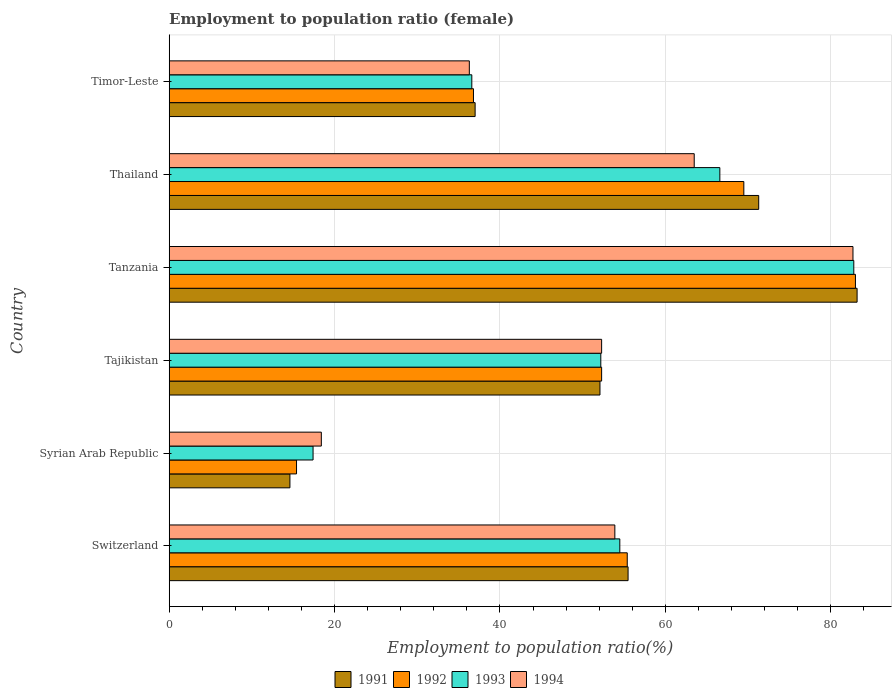Are the number of bars per tick equal to the number of legend labels?
Your answer should be very brief. Yes. How many bars are there on the 1st tick from the bottom?
Give a very brief answer. 4. What is the label of the 1st group of bars from the top?
Give a very brief answer. Timor-Leste. What is the employment to population ratio in 1994 in Syrian Arab Republic?
Offer a very short reply. 18.4. Across all countries, what is the maximum employment to population ratio in 1993?
Give a very brief answer. 82.8. Across all countries, what is the minimum employment to population ratio in 1992?
Give a very brief answer. 15.4. In which country was the employment to population ratio in 1994 maximum?
Make the answer very short. Tanzania. In which country was the employment to population ratio in 1993 minimum?
Your answer should be very brief. Syrian Arab Republic. What is the total employment to population ratio in 1992 in the graph?
Offer a very short reply. 312.4. What is the difference between the employment to population ratio in 1991 in Switzerland and that in Tajikistan?
Offer a terse response. 3.4. What is the difference between the employment to population ratio in 1991 in Syrian Arab Republic and the employment to population ratio in 1994 in Thailand?
Ensure brevity in your answer.  -48.9. What is the average employment to population ratio in 1991 per country?
Ensure brevity in your answer.  52.28. What is the difference between the employment to population ratio in 1993 and employment to population ratio in 1994 in Timor-Leste?
Your answer should be very brief. 0.3. What is the ratio of the employment to population ratio in 1991 in Syrian Arab Republic to that in Timor-Leste?
Your answer should be very brief. 0.39. Is the employment to population ratio in 1993 in Syrian Arab Republic less than that in Tajikistan?
Ensure brevity in your answer.  Yes. Is the difference between the employment to population ratio in 1993 in Tajikistan and Tanzania greater than the difference between the employment to population ratio in 1994 in Tajikistan and Tanzania?
Give a very brief answer. No. What is the difference between the highest and the second highest employment to population ratio in 1992?
Your answer should be very brief. 13.5. What is the difference between the highest and the lowest employment to population ratio in 1994?
Ensure brevity in your answer.  64.3. In how many countries, is the employment to population ratio in 1994 greater than the average employment to population ratio in 1994 taken over all countries?
Make the answer very short. 4. What does the 3rd bar from the top in Timor-Leste represents?
Ensure brevity in your answer.  1992. How many bars are there?
Provide a short and direct response. 24. Are all the bars in the graph horizontal?
Offer a terse response. Yes. How many countries are there in the graph?
Provide a short and direct response. 6. Are the values on the major ticks of X-axis written in scientific E-notation?
Provide a succinct answer. No. Does the graph contain any zero values?
Make the answer very short. No. Does the graph contain grids?
Keep it short and to the point. Yes. Where does the legend appear in the graph?
Your answer should be compact. Bottom center. How many legend labels are there?
Ensure brevity in your answer.  4. How are the legend labels stacked?
Provide a short and direct response. Horizontal. What is the title of the graph?
Your answer should be very brief. Employment to population ratio (female). Does "1978" appear as one of the legend labels in the graph?
Your answer should be compact. No. What is the label or title of the X-axis?
Ensure brevity in your answer.  Employment to population ratio(%). What is the label or title of the Y-axis?
Make the answer very short. Country. What is the Employment to population ratio(%) in 1991 in Switzerland?
Ensure brevity in your answer.  55.5. What is the Employment to population ratio(%) of 1992 in Switzerland?
Your answer should be very brief. 55.4. What is the Employment to population ratio(%) in 1993 in Switzerland?
Your response must be concise. 54.5. What is the Employment to population ratio(%) in 1994 in Switzerland?
Offer a very short reply. 53.9. What is the Employment to population ratio(%) of 1991 in Syrian Arab Republic?
Offer a terse response. 14.6. What is the Employment to population ratio(%) of 1992 in Syrian Arab Republic?
Make the answer very short. 15.4. What is the Employment to population ratio(%) of 1993 in Syrian Arab Republic?
Make the answer very short. 17.4. What is the Employment to population ratio(%) in 1994 in Syrian Arab Republic?
Provide a succinct answer. 18.4. What is the Employment to population ratio(%) in 1991 in Tajikistan?
Provide a succinct answer. 52.1. What is the Employment to population ratio(%) of 1992 in Tajikistan?
Make the answer very short. 52.3. What is the Employment to population ratio(%) in 1993 in Tajikistan?
Your response must be concise. 52.2. What is the Employment to population ratio(%) in 1994 in Tajikistan?
Your answer should be very brief. 52.3. What is the Employment to population ratio(%) in 1991 in Tanzania?
Provide a short and direct response. 83.2. What is the Employment to population ratio(%) of 1993 in Tanzania?
Offer a terse response. 82.8. What is the Employment to population ratio(%) in 1994 in Tanzania?
Offer a very short reply. 82.7. What is the Employment to population ratio(%) in 1991 in Thailand?
Provide a succinct answer. 71.3. What is the Employment to population ratio(%) in 1992 in Thailand?
Your answer should be compact. 69.5. What is the Employment to population ratio(%) in 1993 in Thailand?
Your answer should be compact. 66.6. What is the Employment to population ratio(%) in 1994 in Thailand?
Ensure brevity in your answer.  63.5. What is the Employment to population ratio(%) of 1992 in Timor-Leste?
Your answer should be compact. 36.8. What is the Employment to population ratio(%) of 1993 in Timor-Leste?
Ensure brevity in your answer.  36.6. What is the Employment to population ratio(%) of 1994 in Timor-Leste?
Give a very brief answer. 36.3. Across all countries, what is the maximum Employment to population ratio(%) in 1991?
Your answer should be very brief. 83.2. Across all countries, what is the maximum Employment to population ratio(%) in 1993?
Give a very brief answer. 82.8. Across all countries, what is the maximum Employment to population ratio(%) in 1994?
Offer a terse response. 82.7. Across all countries, what is the minimum Employment to population ratio(%) in 1991?
Your answer should be compact. 14.6. Across all countries, what is the minimum Employment to population ratio(%) in 1992?
Provide a succinct answer. 15.4. Across all countries, what is the minimum Employment to population ratio(%) of 1993?
Provide a short and direct response. 17.4. Across all countries, what is the minimum Employment to population ratio(%) of 1994?
Your answer should be compact. 18.4. What is the total Employment to population ratio(%) of 1991 in the graph?
Provide a short and direct response. 313.7. What is the total Employment to population ratio(%) in 1992 in the graph?
Ensure brevity in your answer.  312.4. What is the total Employment to population ratio(%) of 1993 in the graph?
Give a very brief answer. 310.1. What is the total Employment to population ratio(%) in 1994 in the graph?
Offer a terse response. 307.1. What is the difference between the Employment to population ratio(%) of 1991 in Switzerland and that in Syrian Arab Republic?
Your answer should be compact. 40.9. What is the difference between the Employment to population ratio(%) of 1993 in Switzerland and that in Syrian Arab Republic?
Offer a very short reply. 37.1. What is the difference between the Employment to population ratio(%) in 1994 in Switzerland and that in Syrian Arab Republic?
Provide a short and direct response. 35.5. What is the difference between the Employment to population ratio(%) of 1993 in Switzerland and that in Tajikistan?
Keep it short and to the point. 2.3. What is the difference between the Employment to population ratio(%) of 1994 in Switzerland and that in Tajikistan?
Ensure brevity in your answer.  1.6. What is the difference between the Employment to population ratio(%) of 1991 in Switzerland and that in Tanzania?
Provide a succinct answer. -27.7. What is the difference between the Employment to population ratio(%) of 1992 in Switzerland and that in Tanzania?
Give a very brief answer. -27.6. What is the difference between the Employment to population ratio(%) of 1993 in Switzerland and that in Tanzania?
Your answer should be very brief. -28.3. What is the difference between the Employment to population ratio(%) of 1994 in Switzerland and that in Tanzania?
Ensure brevity in your answer.  -28.8. What is the difference between the Employment to population ratio(%) in 1991 in Switzerland and that in Thailand?
Offer a very short reply. -15.8. What is the difference between the Employment to population ratio(%) of 1992 in Switzerland and that in Thailand?
Give a very brief answer. -14.1. What is the difference between the Employment to population ratio(%) of 1993 in Switzerland and that in Thailand?
Provide a succinct answer. -12.1. What is the difference between the Employment to population ratio(%) of 1991 in Switzerland and that in Timor-Leste?
Your answer should be compact. 18.5. What is the difference between the Employment to population ratio(%) in 1994 in Switzerland and that in Timor-Leste?
Your answer should be very brief. 17.6. What is the difference between the Employment to population ratio(%) in 1991 in Syrian Arab Republic and that in Tajikistan?
Your answer should be very brief. -37.5. What is the difference between the Employment to population ratio(%) in 1992 in Syrian Arab Republic and that in Tajikistan?
Offer a terse response. -36.9. What is the difference between the Employment to population ratio(%) in 1993 in Syrian Arab Republic and that in Tajikistan?
Provide a short and direct response. -34.8. What is the difference between the Employment to population ratio(%) in 1994 in Syrian Arab Republic and that in Tajikistan?
Your answer should be very brief. -33.9. What is the difference between the Employment to population ratio(%) of 1991 in Syrian Arab Republic and that in Tanzania?
Provide a succinct answer. -68.6. What is the difference between the Employment to population ratio(%) in 1992 in Syrian Arab Republic and that in Tanzania?
Provide a succinct answer. -67.6. What is the difference between the Employment to population ratio(%) in 1993 in Syrian Arab Republic and that in Tanzania?
Your answer should be compact. -65.4. What is the difference between the Employment to population ratio(%) in 1994 in Syrian Arab Republic and that in Tanzania?
Your answer should be compact. -64.3. What is the difference between the Employment to population ratio(%) of 1991 in Syrian Arab Republic and that in Thailand?
Your answer should be very brief. -56.7. What is the difference between the Employment to population ratio(%) in 1992 in Syrian Arab Republic and that in Thailand?
Keep it short and to the point. -54.1. What is the difference between the Employment to population ratio(%) of 1993 in Syrian Arab Republic and that in Thailand?
Offer a very short reply. -49.2. What is the difference between the Employment to population ratio(%) in 1994 in Syrian Arab Republic and that in Thailand?
Offer a terse response. -45.1. What is the difference between the Employment to population ratio(%) of 1991 in Syrian Arab Republic and that in Timor-Leste?
Make the answer very short. -22.4. What is the difference between the Employment to population ratio(%) of 1992 in Syrian Arab Republic and that in Timor-Leste?
Keep it short and to the point. -21.4. What is the difference between the Employment to population ratio(%) of 1993 in Syrian Arab Republic and that in Timor-Leste?
Offer a very short reply. -19.2. What is the difference between the Employment to population ratio(%) of 1994 in Syrian Arab Republic and that in Timor-Leste?
Make the answer very short. -17.9. What is the difference between the Employment to population ratio(%) in 1991 in Tajikistan and that in Tanzania?
Make the answer very short. -31.1. What is the difference between the Employment to population ratio(%) of 1992 in Tajikistan and that in Tanzania?
Make the answer very short. -30.7. What is the difference between the Employment to population ratio(%) in 1993 in Tajikistan and that in Tanzania?
Offer a very short reply. -30.6. What is the difference between the Employment to population ratio(%) in 1994 in Tajikistan and that in Tanzania?
Your answer should be very brief. -30.4. What is the difference between the Employment to population ratio(%) of 1991 in Tajikistan and that in Thailand?
Your answer should be compact. -19.2. What is the difference between the Employment to population ratio(%) of 1992 in Tajikistan and that in Thailand?
Make the answer very short. -17.2. What is the difference between the Employment to population ratio(%) in 1993 in Tajikistan and that in Thailand?
Ensure brevity in your answer.  -14.4. What is the difference between the Employment to population ratio(%) of 1994 in Tajikistan and that in Thailand?
Offer a terse response. -11.2. What is the difference between the Employment to population ratio(%) of 1991 in Tajikistan and that in Timor-Leste?
Provide a short and direct response. 15.1. What is the difference between the Employment to population ratio(%) of 1992 in Tajikistan and that in Timor-Leste?
Your answer should be very brief. 15.5. What is the difference between the Employment to population ratio(%) of 1994 in Tajikistan and that in Timor-Leste?
Offer a terse response. 16. What is the difference between the Employment to population ratio(%) in 1992 in Tanzania and that in Thailand?
Offer a terse response. 13.5. What is the difference between the Employment to population ratio(%) of 1993 in Tanzania and that in Thailand?
Your answer should be very brief. 16.2. What is the difference between the Employment to population ratio(%) of 1994 in Tanzania and that in Thailand?
Provide a succinct answer. 19.2. What is the difference between the Employment to population ratio(%) of 1991 in Tanzania and that in Timor-Leste?
Offer a terse response. 46.2. What is the difference between the Employment to population ratio(%) of 1992 in Tanzania and that in Timor-Leste?
Your answer should be very brief. 46.2. What is the difference between the Employment to population ratio(%) of 1993 in Tanzania and that in Timor-Leste?
Offer a terse response. 46.2. What is the difference between the Employment to population ratio(%) in 1994 in Tanzania and that in Timor-Leste?
Provide a short and direct response. 46.4. What is the difference between the Employment to population ratio(%) of 1991 in Thailand and that in Timor-Leste?
Provide a succinct answer. 34.3. What is the difference between the Employment to population ratio(%) in 1992 in Thailand and that in Timor-Leste?
Provide a short and direct response. 32.7. What is the difference between the Employment to population ratio(%) of 1993 in Thailand and that in Timor-Leste?
Offer a very short reply. 30. What is the difference between the Employment to population ratio(%) in 1994 in Thailand and that in Timor-Leste?
Your answer should be very brief. 27.2. What is the difference between the Employment to population ratio(%) in 1991 in Switzerland and the Employment to population ratio(%) in 1992 in Syrian Arab Republic?
Your answer should be compact. 40.1. What is the difference between the Employment to population ratio(%) of 1991 in Switzerland and the Employment to population ratio(%) of 1993 in Syrian Arab Republic?
Give a very brief answer. 38.1. What is the difference between the Employment to population ratio(%) of 1991 in Switzerland and the Employment to population ratio(%) of 1994 in Syrian Arab Republic?
Offer a terse response. 37.1. What is the difference between the Employment to population ratio(%) of 1992 in Switzerland and the Employment to population ratio(%) of 1993 in Syrian Arab Republic?
Provide a short and direct response. 38. What is the difference between the Employment to population ratio(%) in 1993 in Switzerland and the Employment to population ratio(%) in 1994 in Syrian Arab Republic?
Offer a very short reply. 36.1. What is the difference between the Employment to population ratio(%) in 1991 in Switzerland and the Employment to population ratio(%) in 1993 in Tajikistan?
Keep it short and to the point. 3.3. What is the difference between the Employment to population ratio(%) of 1991 in Switzerland and the Employment to population ratio(%) of 1994 in Tajikistan?
Keep it short and to the point. 3.2. What is the difference between the Employment to population ratio(%) in 1992 in Switzerland and the Employment to population ratio(%) in 1993 in Tajikistan?
Your response must be concise. 3.2. What is the difference between the Employment to population ratio(%) of 1991 in Switzerland and the Employment to population ratio(%) of 1992 in Tanzania?
Keep it short and to the point. -27.5. What is the difference between the Employment to population ratio(%) in 1991 in Switzerland and the Employment to population ratio(%) in 1993 in Tanzania?
Make the answer very short. -27.3. What is the difference between the Employment to population ratio(%) in 1991 in Switzerland and the Employment to population ratio(%) in 1994 in Tanzania?
Your answer should be compact. -27.2. What is the difference between the Employment to population ratio(%) of 1992 in Switzerland and the Employment to population ratio(%) of 1993 in Tanzania?
Your answer should be compact. -27.4. What is the difference between the Employment to population ratio(%) of 1992 in Switzerland and the Employment to population ratio(%) of 1994 in Tanzania?
Your response must be concise. -27.3. What is the difference between the Employment to population ratio(%) of 1993 in Switzerland and the Employment to population ratio(%) of 1994 in Tanzania?
Keep it short and to the point. -28.2. What is the difference between the Employment to population ratio(%) of 1991 in Switzerland and the Employment to population ratio(%) of 1992 in Thailand?
Your answer should be very brief. -14. What is the difference between the Employment to population ratio(%) of 1991 in Switzerland and the Employment to population ratio(%) of 1994 in Thailand?
Provide a succinct answer. -8. What is the difference between the Employment to population ratio(%) of 1993 in Switzerland and the Employment to population ratio(%) of 1994 in Thailand?
Your answer should be compact. -9. What is the difference between the Employment to population ratio(%) of 1991 in Switzerland and the Employment to population ratio(%) of 1992 in Timor-Leste?
Offer a terse response. 18.7. What is the difference between the Employment to population ratio(%) of 1991 in Switzerland and the Employment to population ratio(%) of 1993 in Timor-Leste?
Make the answer very short. 18.9. What is the difference between the Employment to population ratio(%) in 1991 in Switzerland and the Employment to population ratio(%) in 1994 in Timor-Leste?
Ensure brevity in your answer.  19.2. What is the difference between the Employment to population ratio(%) of 1992 in Switzerland and the Employment to population ratio(%) of 1993 in Timor-Leste?
Ensure brevity in your answer.  18.8. What is the difference between the Employment to population ratio(%) of 1992 in Switzerland and the Employment to population ratio(%) of 1994 in Timor-Leste?
Make the answer very short. 19.1. What is the difference between the Employment to population ratio(%) in 1993 in Switzerland and the Employment to population ratio(%) in 1994 in Timor-Leste?
Offer a terse response. 18.2. What is the difference between the Employment to population ratio(%) of 1991 in Syrian Arab Republic and the Employment to population ratio(%) of 1992 in Tajikistan?
Offer a terse response. -37.7. What is the difference between the Employment to population ratio(%) of 1991 in Syrian Arab Republic and the Employment to population ratio(%) of 1993 in Tajikistan?
Make the answer very short. -37.6. What is the difference between the Employment to population ratio(%) in 1991 in Syrian Arab Republic and the Employment to population ratio(%) in 1994 in Tajikistan?
Ensure brevity in your answer.  -37.7. What is the difference between the Employment to population ratio(%) of 1992 in Syrian Arab Republic and the Employment to population ratio(%) of 1993 in Tajikistan?
Offer a terse response. -36.8. What is the difference between the Employment to population ratio(%) in 1992 in Syrian Arab Republic and the Employment to population ratio(%) in 1994 in Tajikistan?
Your answer should be compact. -36.9. What is the difference between the Employment to population ratio(%) in 1993 in Syrian Arab Republic and the Employment to population ratio(%) in 1994 in Tajikistan?
Provide a short and direct response. -34.9. What is the difference between the Employment to population ratio(%) in 1991 in Syrian Arab Republic and the Employment to population ratio(%) in 1992 in Tanzania?
Provide a short and direct response. -68.4. What is the difference between the Employment to population ratio(%) in 1991 in Syrian Arab Republic and the Employment to population ratio(%) in 1993 in Tanzania?
Offer a very short reply. -68.2. What is the difference between the Employment to population ratio(%) of 1991 in Syrian Arab Republic and the Employment to population ratio(%) of 1994 in Tanzania?
Your response must be concise. -68.1. What is the difference between the Employment to population ratio(%) of 1992 in Syrian Arab Republic and the Employment to population ratio(%) of 1993 in Tanzania?
Ensure brevity in your answer.  -67.4. What is the difference between the Employment to population ratio(%) of 1992 in Syrian Arab Republic and the Employment to population ratio(%) of 1994 in Tanzania?
Keep it short and to the point. -67.3. What is the difference between the Employment to population ratio(%) of 1993 in Syrian Arab Republic and the Employment to population ratio(%) of 1994 in Tanzania?
Make the answer very short. -65.3. What is the difference between the Employment to population ratio(%) of 1991 in Syrian Arab Republic and the Employment to population ratio(%) of 1992 in Thailand?
Offer a terse response. -54.9. What is the difference between the Employment to population ratio(%) of 1991 in Syrian Arab Republic and the Employment to population ratio(%) of 1993 in Thailand?
Offer a terse response. -52. What is the difference between the Employment to population ratio(%) in 1991 in Syrian Arab Republic and the Employment to population ratio(%) in 1994 in Thailand?
Make the answer very short. -48.9. What is the difference between the Employment to population ratio(%) of 1992 in Syrian Arab Republic and the Employment to population ratio(%) of 1993 in Thailand?
Keep it short and to the point. -51.2. What is the difference between the Employment to population ratio(%) in 1992 in Syrian Arab Republic and the Employment to population ratio(%) in 1994 in Thailand?
Ensure brevity in your answer.  -48.1. What is the difference between the Employment to population ratio(%) of 1993 in Syrian Arab Republic and the Employment to population ratio(%) of 1994 in Thailand?
Make the answer very short. -46.1. What is the difference between the Employment to population ratio(%) in 1991 in Syrian Arab Republic and the Employment to population ratio(%) in 1992 in Timor-Leste?
Provide a short and direct response. -22.2. What is the difference between the Employment to population ratio(%) of 1991 in Syrian Arab Republic and the Employment to population ratio(%) of 1993 in Timor-Leste?
Your response must be concise. -22. What is the difference between the Employment to population ratio(%) of 1991 in Syrian Arab Republic and the Employment to population ratio(%) of 1994 in Timor-Leste?
Your answer should be compact. -21.7. What is the difference between the Employment to population ratio(%) of 1992 in Syrian Arab Republic and the Employment to population ratio(%) of 1993 in Timor-Leste?
Your response must be concise. -21.2. What is the difference between the Employment to population ratio(%) of 1992 in Syrian Arab Republic and the Employment to population ratio(%) of 1994 in Timor-Leste?
Your response must be concise. -20.9. What is the difference between the Employment to population ratio(%) in 1993 in Syrian Arab Republic and the Employment to population ratio(%) in 1994 in Timor-Leste?
Give a very brief answer. -18.9. What is the difference between the Employment to population ratio(%) in 1991 in Tajikistan and the Employment to population ratio(%) in 1992 in Tanzania?
Keep it short and to the point. -30.9. What is the difference between the Employment to population ratio(%) in 1991 in Tajikistan and the Employment to population ratio(%) in 1993 in Tanzania?
Your response must be concise. -30.7. What is the difference between the Employment to population ratio(%) of 1991 in Tajikistan and the Employment to population ratio(%) of 1994 in Tanzania?
Ensure brevity in your answer.  -30.6. What is the difference between the Employment to population ratio(%) of 1992 in Tajikistan and the Employment to population ratio(%) of 1993 in Tanzania?
Your response must be concise. -30.5. What is the difference between the Employment to population ratio(%) in 1992 in Tajikistan and the Employment to population ratio(%) in 1994 in Tanzania?
Your response must be concise. -30.4. What is the difference between the Employment to population ratio(%) in 1993 in Tajikistan and the Employment to population ratio(%) in 1994 in Tanzania?
Provide a short and direct response. -30.5. What is the difference between the Employment to population ratio(%) of 1991 in Tajikistan and the Employment to population ratio(%) of 1992 in Thailand?
Make the answer very short. -17.4. What is the difference between the Employment to population ratio(%) of 1991 in Tajikistan and the Employment to population ratio(%) of 1993 in Thailand?
Give a very brief answer. -14.5. What is the difference between the Employment to population ratio(%) in 1992 in Tajikistan and the Employment to population ratio(%) in 1993 in Thailand?
Your answer should be compact. -14.3. What is the difference between the Employment to population ratio(%) in 1991 in Tajikistan and the Employment to population ratio(%) in 1992 in Timor-Leste?
Ensure brevity in your answer.  15.3. What is the difference between the Employment to population ratio(%) of 1992 in Tajikistan and the Employment to population ratio(%) of 1993 in Timor-Leste?
Your answer should be compact. 15.7. What is the difference between the Employment to population ratio(%) in 1991 in Tanzania and the Employment to population ratio(%) in 1992 in Thailand?
Your response must be concise. 13.7. What is the difference between the Employment to population ratio(%) in 1991 in Tanzania and the Employment to population ratio(%) in 1993 in Thailand?
Provide a succinct answer. 16.6. What is the difference between the Employment to population ratio(%) of 1992 in Tanzania and the Employment to population ratio(%) of 1994 in Thailand?
Your answer should be compact. 19.5. What is the difference between the Employment to population ratio(%) in 1993 in Tanzania and the Employment to population ratio(%) in 1994 in Thailand?
Offer a terse response. 19.3. What is the difference between the Employment to population ratio(%) of 1991 in Tanzania and the Employment to population ratio(%) of 1992 in Timor-Leste?
Make the answer very short. 46.4. What is the difference between the Employment to population ratio(%) of 1991 in Tanzania and the Employment to population ratio(%) of 1993 in Timor-Leste?
Your answer should be very brief. 46.6. What is the difference between the Employment to population ratio(%) of 1991 in Tanzania and the Employment to population ratio(%) of 1994 in Timor-Leste?
Keep it short and to the point. 46.9. What is the difference between the Employment to population ratio(%) in 1992 in Tanzania and the Employment to population ratio(%) in 1993 in Timor-Leste?
Make the answer very short. 46.4. What is the difference between the Employment to population ratio(%) of 1992 in Tanzania and the Employment to population ratio(%) of 1994 in Timor-Leste?
Your answer should be very brief. 46.7. What is the difference between the Employment to population ratio(%) in 1993 in Tanzania and the Employment to population ratio(%) in 1994 in Timor-Leste?
Keep it short and to the point. 46.5. What is the difference between the Employment to population ratio(%) in 1991 in Thailand and the Employment to population ratio(%) in 1992 in Timor-Leste?
Offer a very short reply. 34.5. What is the difference between the Employment to population ratio(%) in 1991 in Thailand and the Employment to population ratio(%) in 1993 in Timor-Leste?
Give a very brief answer. 34.7. What is the difference between the Employment to population ratio(%) in 1991 in Thailand and the Employment to population ratio(%) in 1994 in Timor-Leste?
Your answer should be very brief. 35. What is the difference between the Employment to population ratio(%) in 1992 in Thailand and the Employment to population ratio(%) in 1993 in Timor-Leste?
Your response must be concise. 32.9. What is the difference between the Employment to population ratio(%) in 1992 in Thailand and the Employment to population ratio(%) in 1994 in Timor-Leste?
Keep it short and to the point. 33.2. What is the difference between the Employment to population ratio(%) of 1993 in Thailand and the Employment to population ratio(%) of 1994 in Timor-Leste?
Your response must be concise. 30.3. What is the average Employment to population ratio(%) of 1991 per country?
Your response must be concise. 52.28. What is the average Employment to population ratio(%) in 1992 per country?
Provide a short and direct response. 52.07. What is the average Employment to population ratio(%) in 1993 per country?
Provide a short and direct response. 51.68. What is the average Employment to population ratio(%) of 1994 per country?
Your answer should be compact. 51.18. What is the difference between the Employment to population ratio(%) of 1991 and Employment to population ratio(%) of 1994 in Switzerland?
Make the answer very short. 1.6. What is the difference between the Employment to population ratio(%) of 1992 and Employment to population ratio(%) of 1994 in Switzerland?
Give a very brief answer. 1.5. What is the difference between the Employment to population ratio(%) in 1992 and Employment to population ratio(%) in 1993 in Syrian Arab Republic?
Provide a short and direct response. -2. What is the difference between the Employment to population ratio(%) in 1992 and Employment to population ratio(%) in 1994 in Syrian Arab Republic?
Your answer should be very brief. -3. What is the difference between the Employment to population ratio(%) in 1993 and Employment to population ratio(%) in 1994 in Syrian Arab Republic?
Ensure brevity in your answer.  -1. What is the difference between the Employment to population ratio(%) in 1991 and Employment to population ratio(%) in 1992 in Tajikistan?
Make the answer very short. -0.2. What is the difference between the Employment to population ratio(%) in 1991 and Employment to population ratio(%) in 1994 in Tajikistan?
Your answer should be very brief. -0.2. What is the difference between the Employment to population ratio(%) of 1993 and Employment to population ratio(%) of 1994 in Tajikistan?
Keep it short and to the point. -0.1. What is the difference between the Employment to population ratio(%) in 1991 and Employment to population ratio(%) in 1992 in Tanzania?
Provide a succinct answer. 0.2. What is the difference between the Employment to population ratio(%) of 1991 and Employment to population ratio(%) of 1994 in Tanzania?
Provide a succinct answer. 0.5. What is the difference between the Employment to population ratio(%) of 1992 and Employment to population ratio(%) of 1993 in Tanzania?
Give a very brief answer. 0.2. What is the difference between the Employment to population ratio(%) of 1992 and Employment to population ratio(%) of 1994 in Tanzania?
Offer a very short reply. 0.3. What is the difference between the Employment to population ratio(%) of 1991 and Employment to population ratio(%) of 1992 in Thailand?
Keep it short and to the point. 1.8. What is the difference between the Employment to population ratio(%) of 1991 and Employment to population ratio(%) of 1993 in Thailand?
Your answer should be very brief. 4.7. What is the difference between the Employment to population ratio(%) in 1993 and Employment to population ratio(%) in 1994 in Thailand?
Your answer should be compact. 3.1. What is the difference between the Employment to population ratio(%) in 1991 and Employment to population ratio(%) in 1994 in Timor-Leste?
Your answer should be very brief. 0.7. What is the difference between the Employment to population ratio(%) of 1992 and Employment to population ratio(%) of 1993 in Timor-Leste?
Your answer should be very brief. 0.2. What is the difference between the Employment to population ratio(%) in 1992 and Employment to population ratio(%) in 1994 in Timor-Leste?
Your answer should be very brief. 0.5. What is the ratio of the Employment to population ratio(%) of 1991 in Switzerland to that in Syrian Arab Republic?
Keep it short and to the point. 3.8. What is the ratio of the Employment to population ratio(%) of 1992 in Switzerland to that in Syrian Arab Republic?
Provide a short and direct response. 3.6. What is the ratio of the Employment to population ratio(%) of 1993 in Switzerland to that in Syrian Arab Republic?
Ensure brevity in your answer.  3.13. What is the ratio of the Employment to population ratio(%) of 1994 in Switzerland to that in Syrian Arab Republic?
Your answer should be compact. 2.93. What is the ratio of the Employment to population ratio(%) of 1991 in Switzerland to that in Tajikistan?
Your answer should be very brief. 1.07. What is the ratio of the Employment to population ratio(%) in 1992 in Switzerland to that in Tajikistan?
Your answer should be very brief. 1.06. What is the ratio of the Employment to population ratio(%) in 1993 in Switzerland to that in Tajikistan?
Your answer should be compact. 1.04. What is the ratio of the Employment to population ratio(%) of 1994 in Switzerland to that in Tajikistan?
Provide a succinct answer. 1.03. What is the ratio of the Employment to population ratio(%) in 1991 in Switzerland to that in Tanzania?
Give a very brief answer. 0.67. What is the ratio of the Employment to population ratio(%) of 1992 in Switzerland to that in Tanzania?
Make the answer very short. 0.67. What is the ratio of the Employment to population ratio(%) of 1993 in Switzerland to that in Tanzania?
Your response must be concise. 0.66. What is the ratio of the Employment to population ratio(%) in 1994 in Switzerland to that in Tanzania?
Provide a succinct answer. 0.65. What is the ratio of the Employment to population ratio(%) of 1991 in Switzerland to that in Thailand?
Your answer should be compact. 0.78. What is the ratio of the Employment to population ratio(%) of 1992 in Switzerland to that in Thailand?
Your answer should be very brief. 0.8. What is the ratio of the Employment to population ratio(%) in 1993 in Switzerland to that in Thailand?
Your response must be concise. 0.82. What is the ratio of the Employment to population ratio(%) of 1994 in Switzerland to that in Thailand?
Provide a succinct answer. 0.85. What is the ratio of the Employment to population ratio(%) in 1992 in Switzerland to that in Timor-Leste?
Keep it short and to the point. 1.51. What is the ratio of the Employment to population ratio(%) in 1993 in Switzerland to that in Timor-Leste?
Keep it short and to the point. 1.49. What is the ratio of the Employment to population ratio(%) in 1994 in Switzerland to that in Timor-Leste?
Offer a terse response. 1.48. What is the ratio of the Employment to population ratio(%) of 1991 in Syrian Arab Republic to that in Tajikistan?
Offer a terse response. 0.28. What is the ratio of the Employment to population ratio(%) of 1992 in Syrian Arab Republic to that in Tajikistan?
Offer a terse response. 0.29. What is the ratio of the Employment to population ratio(%) of 1994 in Syrian Arab Republic to that in Tajikistan?
Keep it short and to the point. 0.35. What is the ratio of the Employment to population ratio(%) of 1991 in Syrian Arab Republic to that in Tanzania?
Give a very brief answer. 0.18. What is the ratio of the Employment to population ratio(%) of 1992 in Syrian Arab Republic to that in Tanzania?
Provide a succinct answer. 0.19. What is the ratio of the Employment to population ratio(%) in 1993 in Syrian Arab Republic to that in Tanzania?
Offer a very short reply. 0.21. What is the ratio of the Employment to population ratio(%) of 1994 in Syrian Arab Republic to that in Tanzania?
Offer a terse response. 0.22. What is the ratio of the Employment to population ratio(%) in 1991 in Syrian Arab Republic to that in Thailand?
Your response must be concise. 0.2. What is the ratio of the Employment to population ratio(%) of 1992 in Syrian Arab Republic to that in Thailand?
Give a very brief answer. 0.22. What is the ratio of the Employment to population ratio(%) of 1993 in Syrian Arab Republic to that in Thailand?
Your response must be concise. 0.26. What is the ratio of the Employment to population ratio(%) in 1994 in Syrian Arab Republic to that in Thailand?
Your response must be concise. 0.29. What is the ratio of the Employment to population ratio(%) of 1991 in Syrian Arab Republic to that in Timor-Leste?
Keep it short and to the point. 0.39. What is the ratio of the Employment to population ratio(%) of 1992 in Syrian Arab Republic to that in Timor-Leste?
Keep it short and to the point. 0.42. What is the ratio of the Employment to population ratio(%) of 1993 in Syrian Arab Republic to that in Timor-Leste?
Provide a short and direct response. 0.48. What is the ratio of the Employment to population ratio(%) of 1994 in Syrian Arab Republic to that in Timor-Leste?
Your response must be concise. 0.51. What is the ratio of the Employment to population ratio(%) in 1991 in Tajikistan to that in Tanzania?
Provide a short and direct response. 0.63. What is the ratio of the Employment to population ratio(%) of 1992 in Tajikistan to that in Tanzania?
Keep it short and to the point. 0.63. What is the ratio of the Employment to population ratio(%) in 1993 in Tajikistan to that in Tanzania?
Your answer should be compact. 0.63. What is the ratio of the Employment to population ratio(%) of 1994 in Tajikistan to that in Tanzania?
Give a very brief answer. 0.63. What is the ratio of the Employment to population ratio(%) of 1991 in Tajikistan to that in Thailand?
Your answer should be compact. 0.73. What is the ratio of the Employment to population ratio(%) of 1992 in Tajikistan to that in Thailand?
Provide a short and direct response. 0.75. What is the ratio of the Employment to population ratio(%) in 1993 in Tajikistan to that in Thailand?
Keep it short and to the point. 0.78. What is the ratio of the Employment to population ratio(%) of 1994 in Tajikistan to that in Thailand?
Keep it short and to the point. 0.82. What is the ratio of the Employment to population ratio(%) of 1991 in Tajikistan to that in Timor-Leste?
Your answer should be compact. 1.41. What is the ratio of the Employment to population ratio(%) of 1992 in Tajikistan to that in Timor-Leste?
Offer a terse response. 1.42. What is the ratio of the Employment to population ratio(%) in 1993 in Tajikistan to that in Timor-Leste?
Provide a short and direct response. 1.43. What is the ratio of the Employment to population ratio(%) in 1994 in Tajikistan to that in Timor-Leste?
Provide a succinct answer. 1.44. What is the ratio of the Employment to population ratio(%) of 1991 in Tanzania to that in Thailand?
Keep it short and to the point. 1.17. What is the ratio of the Employment to population ratio(%) of 1992 in Tanzania to that in Thailand?
Offer a terse response. 1.19. What is the ratio of the Employment to population ratio(%) in 1993 in Tanzania to that in Thailand?
Offer a terse response. 1.24. What is the ratio of the Employment to population ratio(%) in 1994 in Tanzania to that in Thailand?
Your response must be concise. 1.3. What is the ratio of the Employment to population ratio(%) in 1991 in Tanzania to that in Timor-Leste?
Your answer should be very brief. 2.25. What is the ratio of the Employment to population ratio(%) of 1992 in Tanzania to that in Timor-Leste?
Offer a terse response. 2.26. What is the ratio of the Employment to population ratio(%) in 1993 in Tanzania to that in Timor-Leste?
Provide a succinct answer. 2.26. What is the ratio of the Employment to population ratio(%) in 1994 in Tanzania to that in Timor-Leste?
Keep it short and to the point. 2.28. What is the ratio of the Employment to population ratio(%) in 1991 in Thailand to that in Timor-Leste?
Ensure brevity in your answer.  1.93. What is the ratio of the Employment to population ratio(%) in 1992 in Thailand to that in Timor-Leste?
Provide a short and direct response. 1.89. What is the ratio of the Employment to population ratio(%) of 1993 in Thailand to that in Timor-Leste?
Ensure brevity in your answer.  1.82. What is the ratio of the Employment to population ratio(%) of 1994 in Thailand to that in Timor-Leste?
Offer a very short reply. 1.75. What is the difference between the highest and the second highest Employment to population ratio(%) in 1993?
Your answer should be compact. 16.2. What is the difference between the highest and the lowest Employment to population ratio(%) in 1991?
Give a very brief answer. 68.6. What is the difference between the highest and the lowest Employment to population ratio(%) of 1992?
Offer a terse response. 67.6. What is the difference between the highest and the lowest Employment to population ratio(%) in 1993?
Your response must be concise. 65.4. What is the difference between the highest and the lowest Employment to population ratio(%) in 1994?
Offer a terse response. 64.3. 